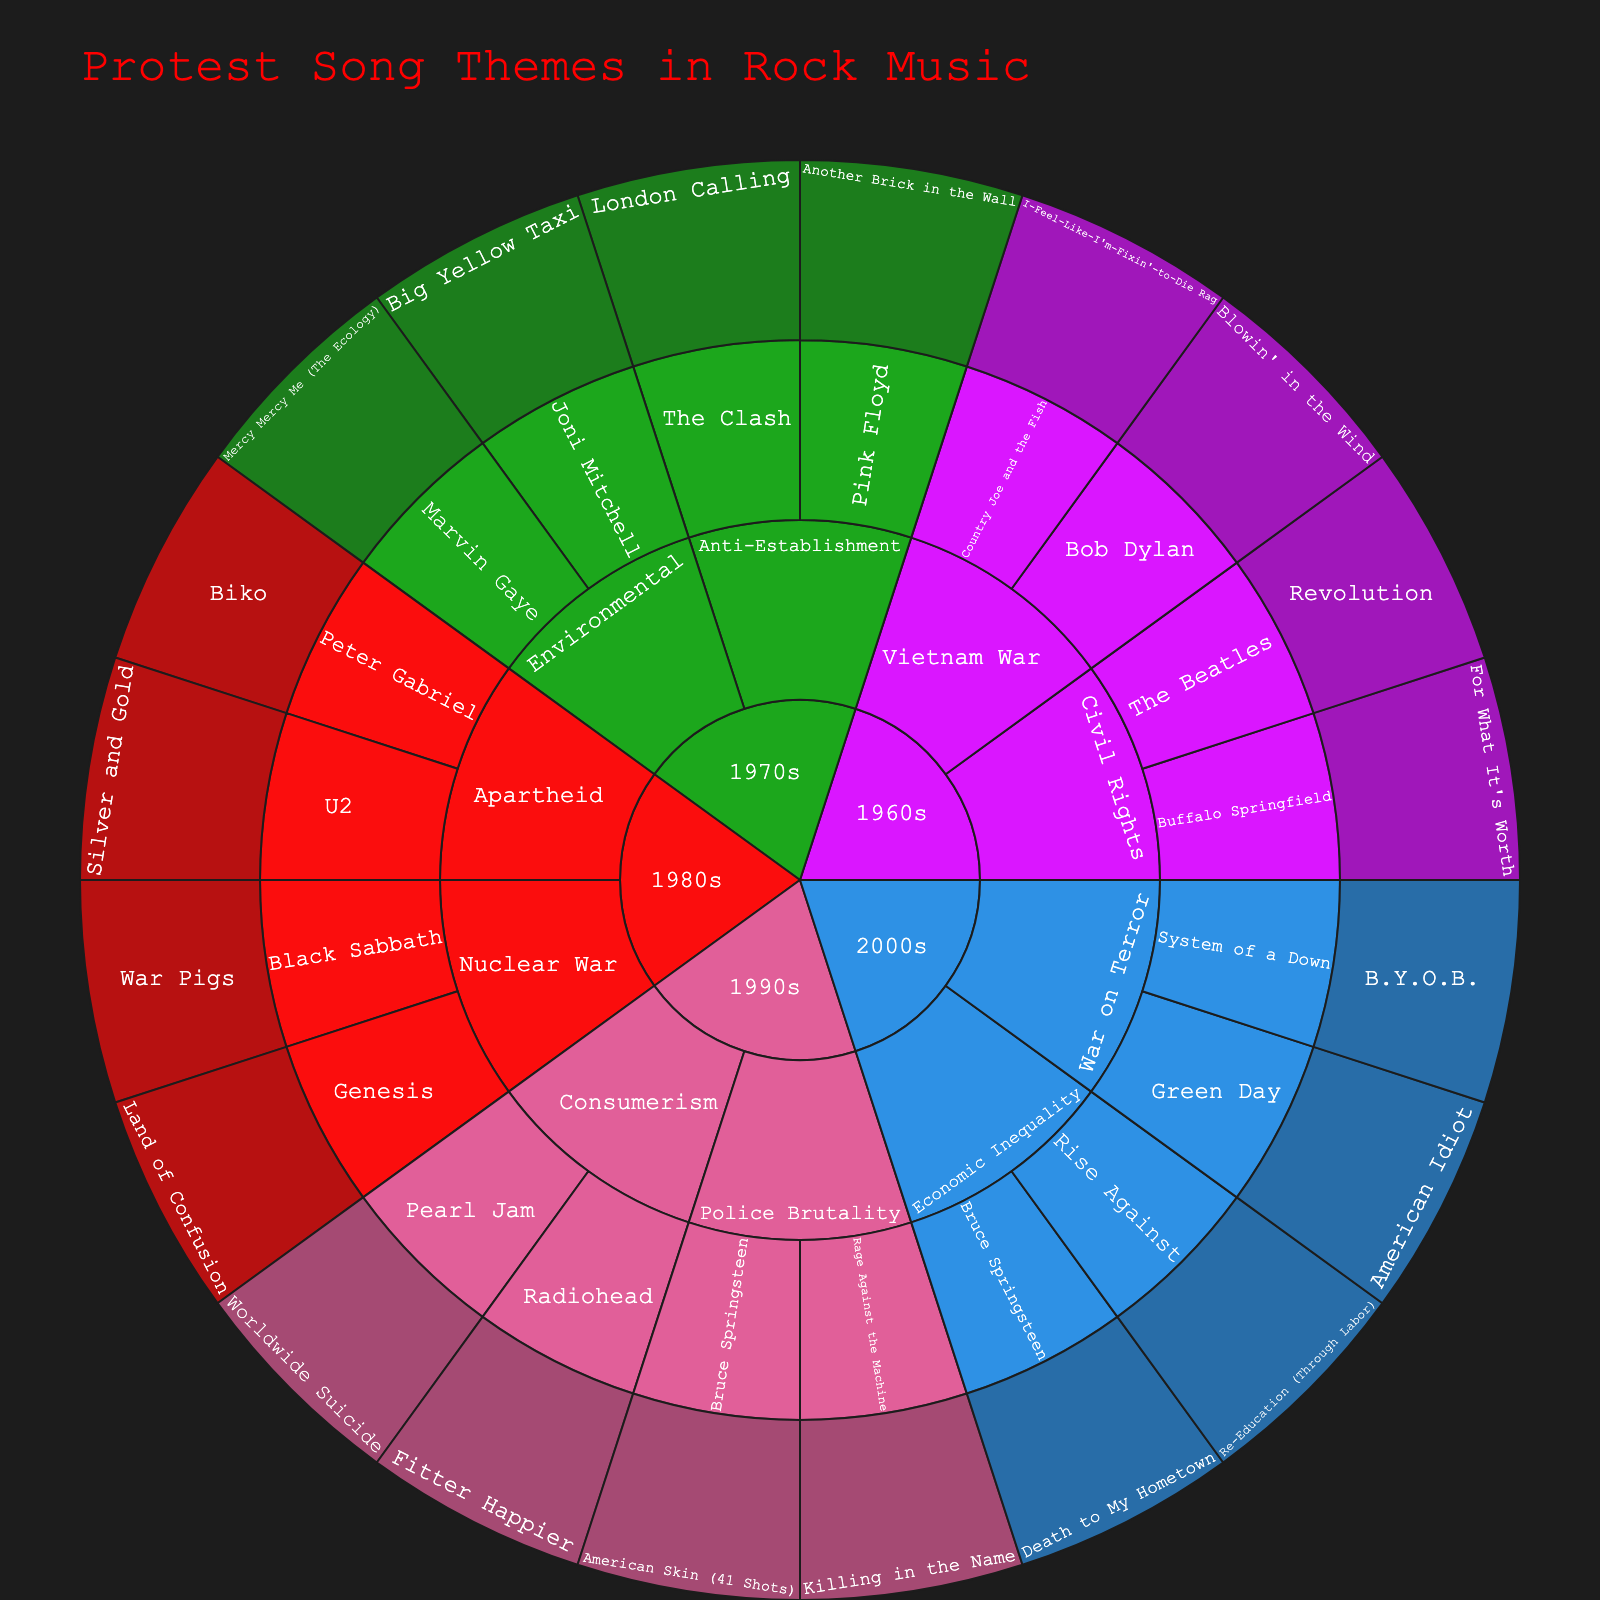What's the title of the sunburst plot? The title is usually displayed prominently at the top of the plot, written in a larger and often differently colored font.
Answer: Protest Song Themes in Rock Music Which decade has the most social issues represented in the plot? To determine this, count the number of unique social issues under each era (1960s, 1970s, 1980s, 1990s, 2000s). The era with the highest count has the most social issues represented.
Answer: 1980s Which social issue is associated with the song 'London Calling'? Locate the song 'London Calling' on the sunburst plot and follow its path outward to see which social issue it falls under.
Answer: Anti-Establishment How many artists from the 1970s are included in the plot? Navigate to the 1970s section of the sunburst plot, then count all unique artist names present in that era.
Answer: 4 Which two artists in the 2000s have songs about Economic Inequality? Find the 2000s segment on the plot, then locate the social issue 'Economic Inequality' within that era and list the artists under it.
Answer: Bruce Springsteen, Rise Against Compare the number of songs about Nuclear War in the 1980s with the number of songs about the Vietnam War in the 1960s. Which has more? Count the songs under the Nuclear War issue in the 1980s, then count the songs under the Vietnam War issue in the 1960s. Compare these counts to find which is greater.
Answer: Equal Which artist from the 1980s has a song addressing Apartheid? Navigate to the 1980s section, then find the social issue 'Apartheid' and note the artist(s) listed under it.
Answer: Peter Gabriel In which era is 'Blowin' in the Wind' categorized and what social issue does it address? Locate the song 'Blowin' in the Wind' in the plot and follow its path outward to determine its era and the social issue it addresses.
Answer: 1960s, Vietnam War Identify the era in which Pink Floyd's 'Another Brick in the Wall' was released and the social issue it addresses. Locate the song 'Another Brick in the Wall,' follow its path outward to find the era and the associated social issue.
Answer: 1970s, Anti-Establishment 